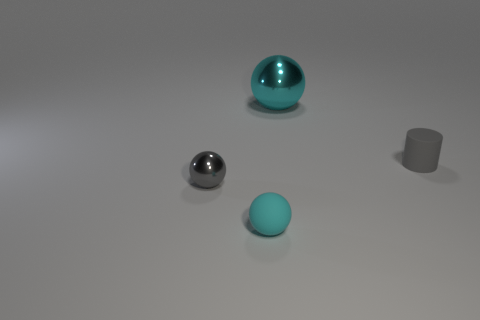There is a gray object that is the same shape as the tiny cyan rubber thing; what is it made of?
Keep it short and to the point. Metal. What is the shape of the thing that is the same color as the big ball?
Provide a short and direct response. Sphere. Do the sphere in front of the gray metallic sphere and the shiny ball to the right of the tiny gray metal ball have the same color?
Give a very brief answer. Yes. What number of things are both on the right side of the gray metal object and in front of the tiny rubber cylinder?
Give a very brief answer. 1. What is the small cyan object made of?
Provide a succinct answer. Rubber. The gray shiny object that is the same size as the matte ball is what shape?
Provide a succinct answer. Sphere. Do the cyan object that is to the right of the small cyan object and the tiny gray object left of the large metal sphere have the same material?
Offer a very short reply. Yes. What number of cyan objects are there?
Offer a terse response. 2. How many small cyan things have the same shape as the gray metallic thing?
Keep it short and to the point. 1. Does the gray shiny thing have the same shape as the big metallic thing?
Ensure brevity in your answer.  Yes. 